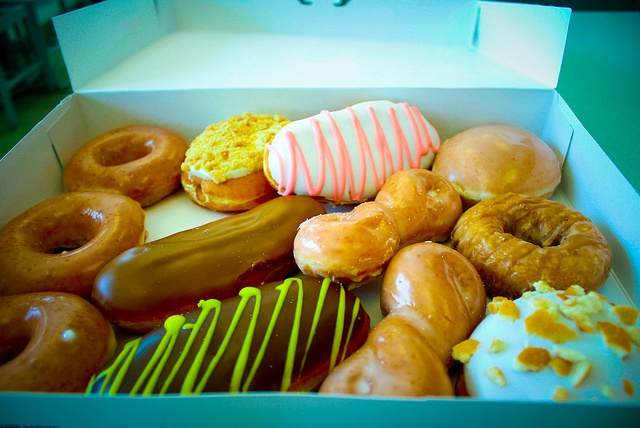Describe the objects in this image and their specific colors. I can see donut in black, olive, and maroon tones, donut in black, lightblue, olive, and teal tones, donut in black, maroon, and olive tones, donut in black, lightgray, salmon, and tan tones, and donut in black, olive, and maroon tones in this image. 